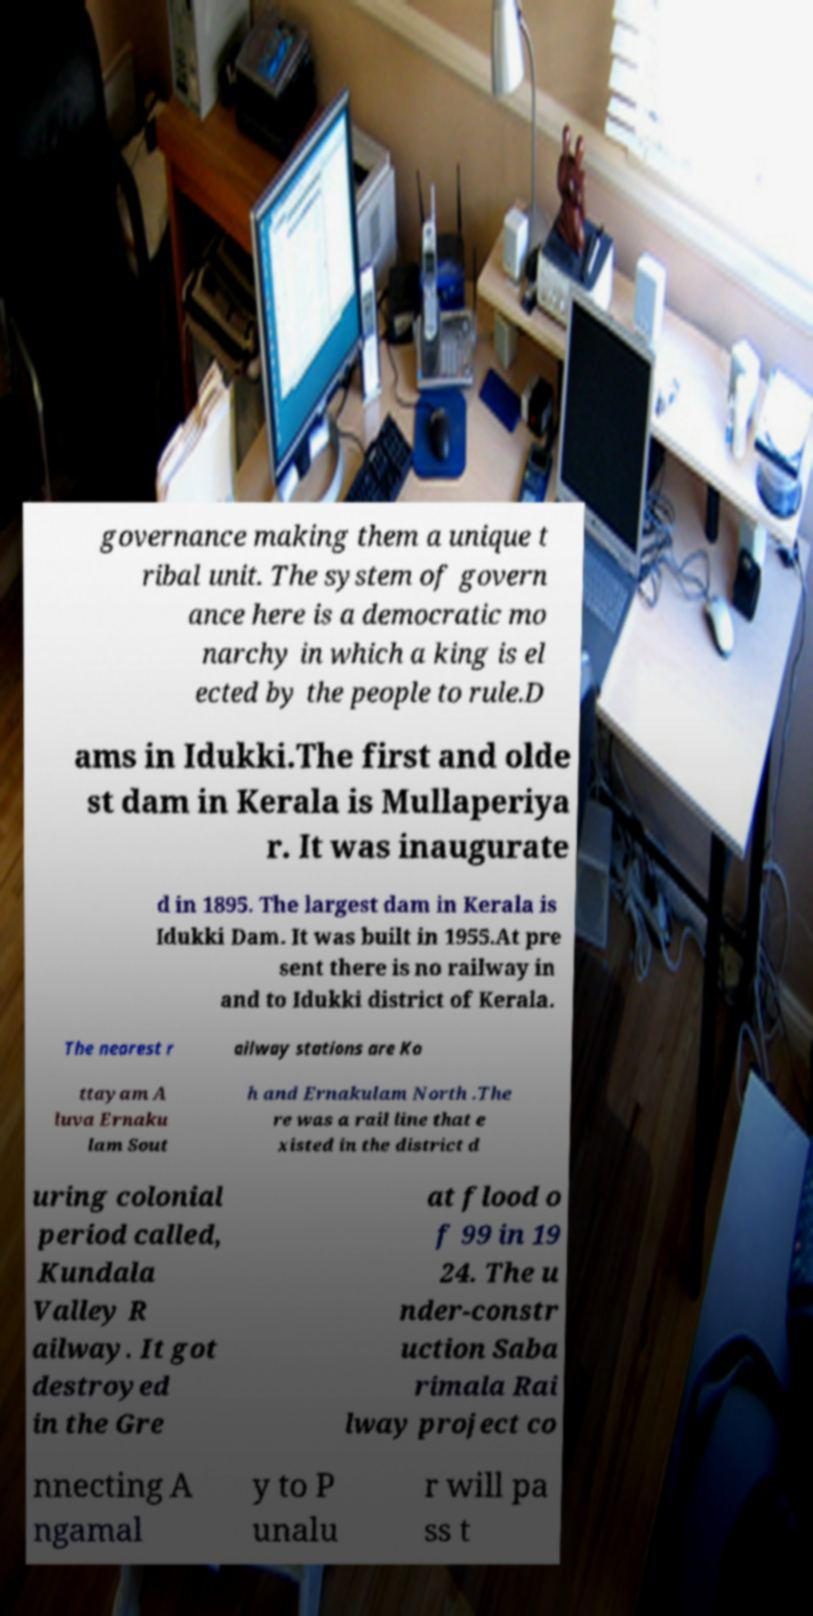Please identify and transcribe the text found in this image. governance making them a unique t ribal unit. The system of govern ance here is a democratic mo narchy in which a king is el ected by the people to rule.D ams in Idukki.The first and olde st dam in Kerala is Mullaperiya r. It was inaugurate d in 1895. The largest dam in Kerala is Idukki Dam. It was built in 1955.At pre sent there is no railway in and to Idukki district of Kerala. The nearest r ailway stations are Ko ttayam A luva Ernaku lam Sout h and Ernakulam North .The re was a rail line that e xisted in the district d uring colonial period called, Kundala Valley R ailway. It got destroyed in the Gre at flood o f 99 in 19 24. The u nder-constr uction Saba rimala Rai lway project co nnecting A ngamal y to P unalu r will pa ss t 